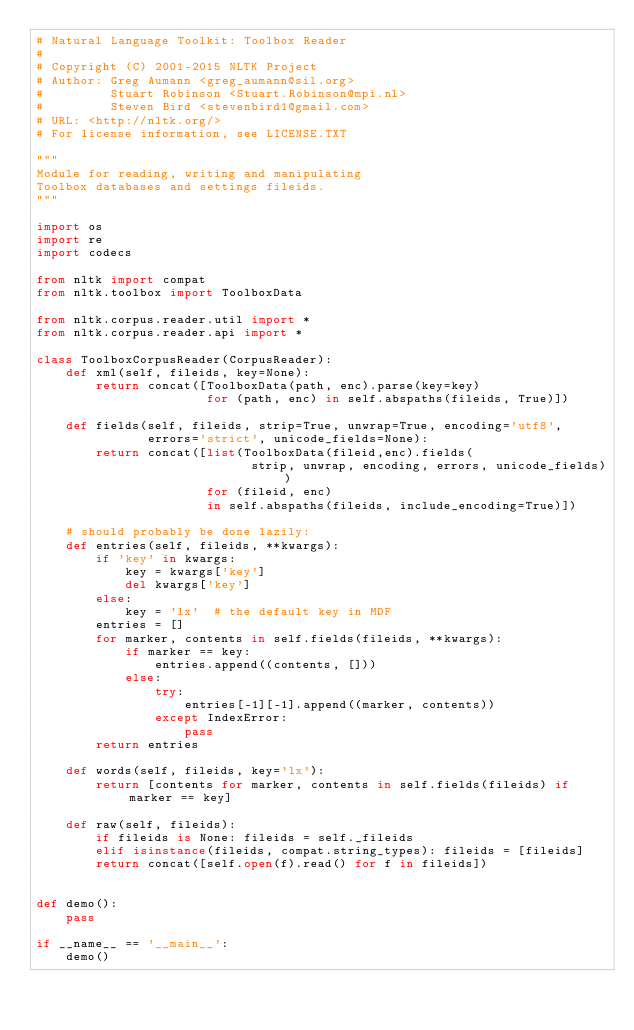<code> <loc_0><loc_0><loc_500><loc_500><_Python_># Natural Language Toolkit: Toolbox Reader
#
# Copyright (C) 2001-2015 NLTK Project
# Author: Greg Aumann <greg_aumann@sil.org>
#         Stuart Robinson <Stuart.Robinson@mpi.nl>
#         Steven Bird <stevenbird1@gmail.com>
# URL: <http://nltk.org/>
# For license information, see LICENSE.TXT

"""
Module for reading, writing and manipulating
Toolbox databases and settings fileids.
"""

import os
import re
import codecs

from nltk import compat
from nltk.toolbox import ToolboxData

from nltk.corpus.reader.util import *
from nltk.corpus.reader.api import *

class ToolboxCorpusReader(CorpusReader):
    def xml(self, fileids, key=None):
        return concat([ToolboxData(path, enc).parse(key=key)
                       for (path, enc) in self.abspaths(fileids, True)])

    def fields(self, fileids, strip=True, unwrap=True, encoding='utf8',
               errors='strict', unicode_fields=None):
        return concat([list(ToolboxData(fileid,enc).fields(
                             strip, unwrap, encoding, errors, unicode_fields))
                       for (fileid, enc)
                       in self.abspaths(fileids, include_encoding=True)])

    # should probably be done lazily:
    def entries(self, fileids, **kwargs):
        if 'key' in kwargs:
            key = kwargs['key']
            del kwargs['key']
        else:
            key = 'lx'  # the default key in MDF
        entries = []
        for marker, contents in self.fields(fileids, **kwargs):
            if marker == key:
                entries.append((contents, []))
            else:
                try:
                    entries[-1][-1].append((marker, contents))
                except IndexError:
                    pass
        return entries

    def words(self, fileids, key='lx'):
        return [contents for marker, contents in self.fields(fileids) if marker == key]

    def raw(self, fileids):
        if fileids is None: fileids = self._fileids
        elif isinstance(fileids, compat.string_types): fileids = [fileids]
        return concat([self.open(f).read() for f in fileids])


def demo():
    pass

if __name__ == '__main__':
    demo()
</code> 